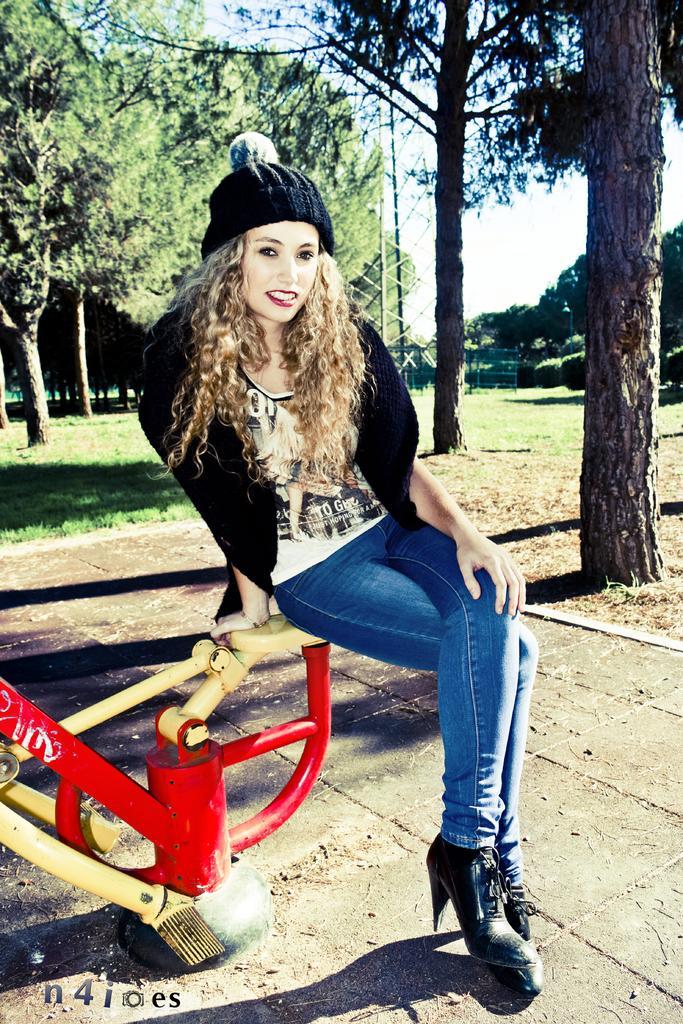Can you describe this image briefly? In this picture, we see the woman in the white T-shirt and a black cap is sitting on the seesaw. It is in red and yellow color. She is smiling and she is posing for the photo. At the bottom, we see the pavement. On the right side, we see the trees and the grass. There are trees, railing, power transformer and the sky in the background. 